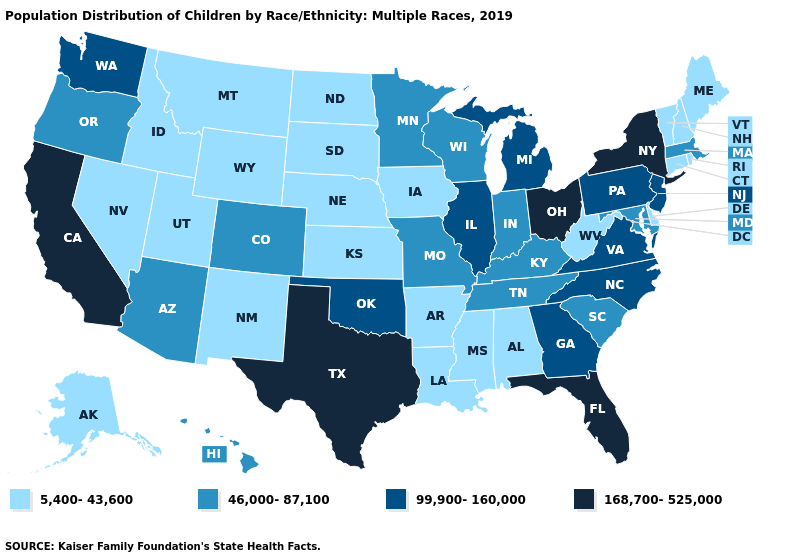Name the states that have a value in the range 5,400-43,600?
Give a very brief answer. Alabama, Alaska, Arkansas, Connecticut, Delaware, Idaho, Iowa, Kansas, Louisiana, Maine, Mississippi, Montana, Nebraska, Nevada, New Hampshire, New Mexico, North Dakota, Rhode Island, South Dakota, Utah, Vermont, West Virginia, Wyoming. What is the value of Alaska?
Quick response, please. 5,400-43,600. Does West Virginia have the lowest value in the USA?
Concise answer only. Yes. What is the value of South Dakota?
Keep it brief. 5,400-43,600. Name the states that have a value in the range 99,900-160,000?
Answer briefly. Georgia, Illinois, Michigan, New Jersey, North Carolina, Oklahoma, Pennsylvania, Virginia, Washington. Is the legend a continuous bar?
Concise answer only. No. What is the lowest value in states that border North Dakota?
Quick response, please. 5,400-43,600. What is the highest value in states that border North Dakota?
Short answer required. 46,000-87,100. What is the value of Missouri?
Give a very brief answer. 46,000-87,100. Does Nebraska have a lower value than New York?
Answer briefly. Yes. What is the value of Hawaii?
Quick response, please. 46,000-87,100. What is the value of Florida?
Keep it brief. 168,700-525,000. Does Mississippi have the lowest value in the USA?
Keep it brief. Yes. What is the highest value in states that border Maryland?
Be succinct. 99,900-160,000. Is the legend a continuous bar?
Answer briefly. No. 